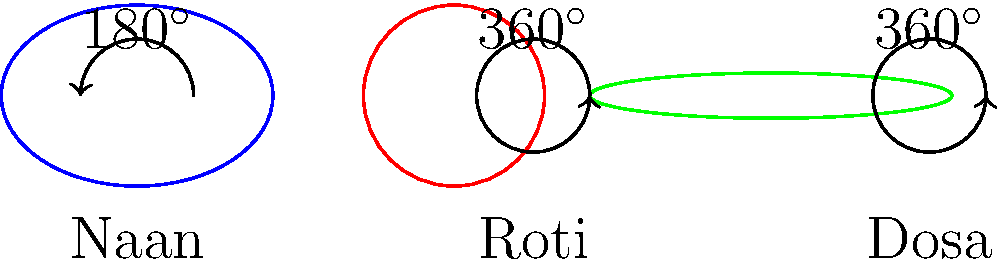Based on the shapes of these popular Indian breads and their associated angles, which bread is typically cooked on only one side, and how does this relate to its shape and cooking technique? Let's analyze each bread based on its shape and associated angle:

1. Naan:
   - Shape: Elongated oval
   - Angle: 180°
   - This indicates it's typically cooked on one side

2. Roti:
   - Shape: Circular
   - Angle: 360°
   - This suggests it's cooked on both sides

3. Dosa:
   - Shape: Large, thin circle
   - Angle: 360°
   - This also suggests it's cooked on both sides, but in a different manner

The bread cooked on only one side is the naan. This relates to its shape and cooking technique in the following ways:

1. Shape: The elongated oval shape of naan allows for easy handling in a tandoor (clay oven).

2. Cooking technique: 
   - Naan is traditionally cooked in a tandoor, where it's stuck to the inner walls.
   - The side facing the hot walls cooks quickly, while the exposed side is cooked by the ambient heat in the tandoor.
   - This one-sided direct heat exposure is represented by the 180° angle in the diagram.

3. Texture: This cooking method results in a bread that's crispy and charred on one side, while soft and bubbly on the other.

In contrast, roti and dosa have 360° angles, indicating they're flipped during cooking to ensure even heating on both sides, albeit using different methods and resulting in different textures.
Answer: Naan, due to its 180° angle and tandoor cooking method 